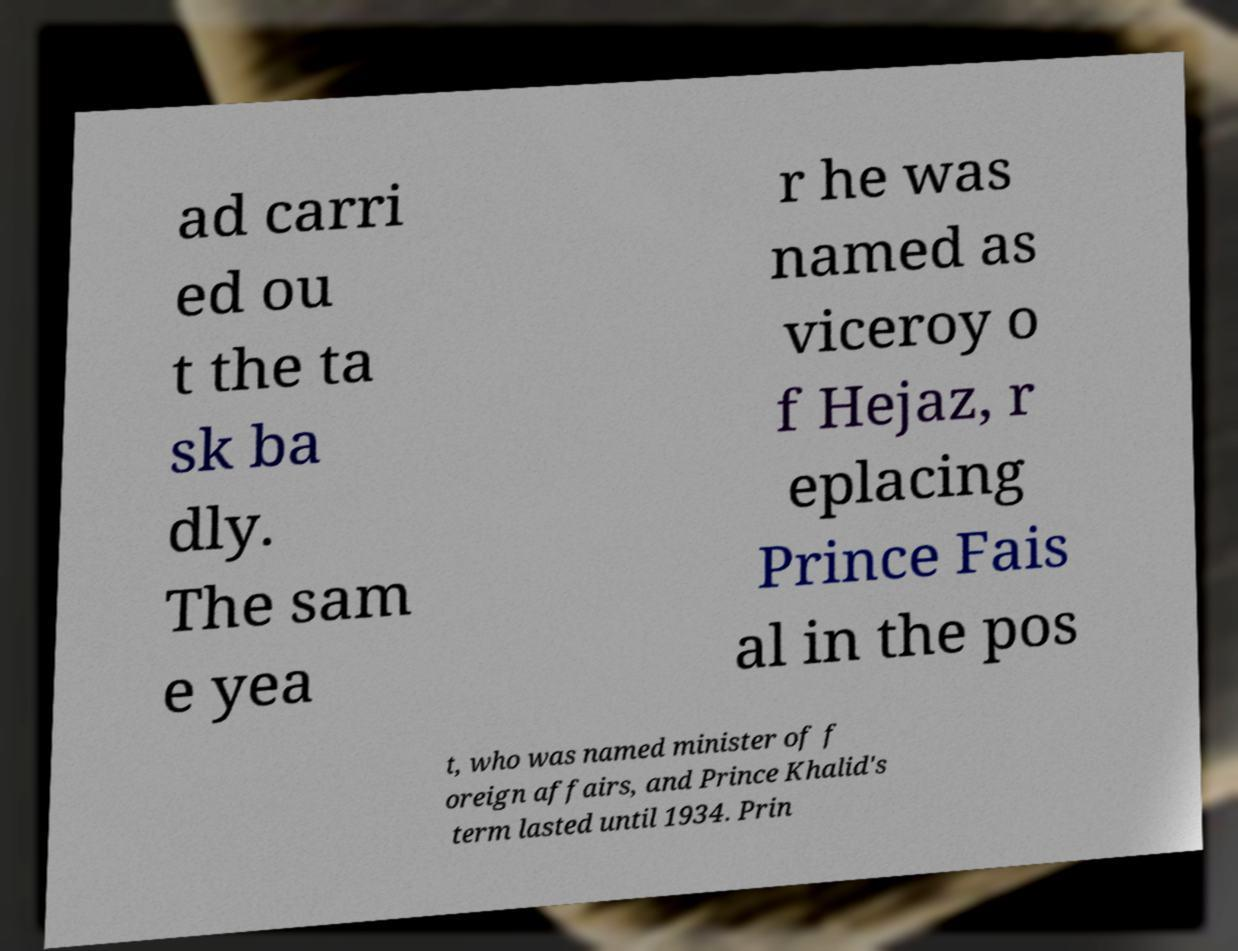For documentation purposes, I need the text within this image transcribed. Could you provide that? ad carri ed ou t the ta sk ba dly. The sam e yea r he was named as viceroy o f Hejaz, r eplacing Prince Fais al in the pos t, who was named minister of f oreign affairs, and Prince Khalid's term lasted until 1934. Prin 